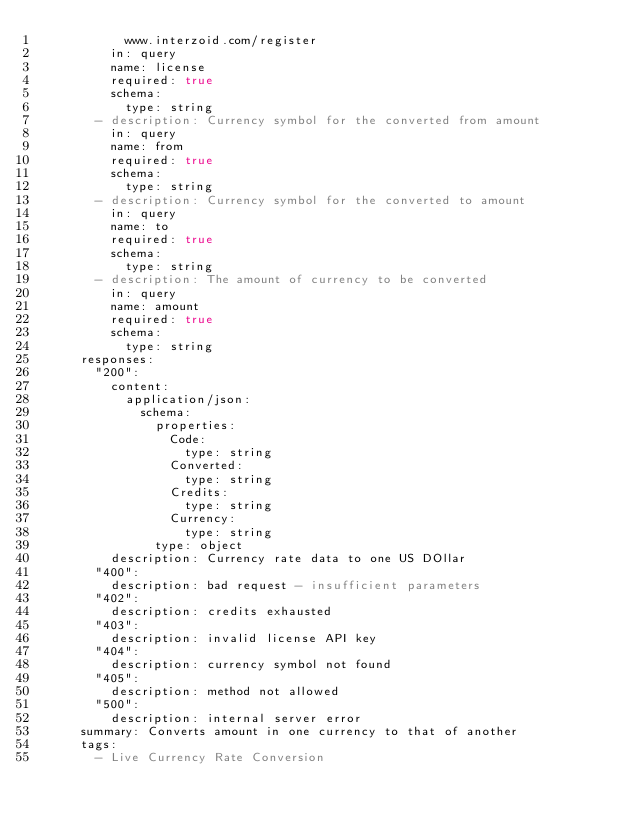Convert code to text. <code><loc_0><loc_0><loc_500><loc_500><_YAML_>            www.interzoid.com/register
          in: query
          name: license
          required: true
          schema:
            type: string
        - description: Currency symbol for the converted from amount
          in: query
          name: from
          required: true
          schema:
            type: string
        - description: Currency symbol for the converted to amount
          in: query
          name: to
          required: true
          schema:
            type: string
        - description: The amount of currency to be converted
          in: query
          name: amount
          required: true
          schema:
            type: string
      responses:
        "200":
          content:
            application/json:
              schema:
                properties:
                  Code:
                    type: string
                  Converted:
                    type: string
                  Credits:
                    type: string
                  Currency:
                    type: string
                type: object
          description: Currency rate data to one US DOllar
        "400":
          description: bad request - insufficient parameters
        "402":
          description: credits exhausted
        "403":
          description: invalid license API key
        "404":
          description: currency symbol not found
        "405":
          description: method not allowed
        "500":
          description: internal server error
      summary: Converts amount in one currency to that of another
      tags:
        - Live Currency Rate Conversion
</code> 